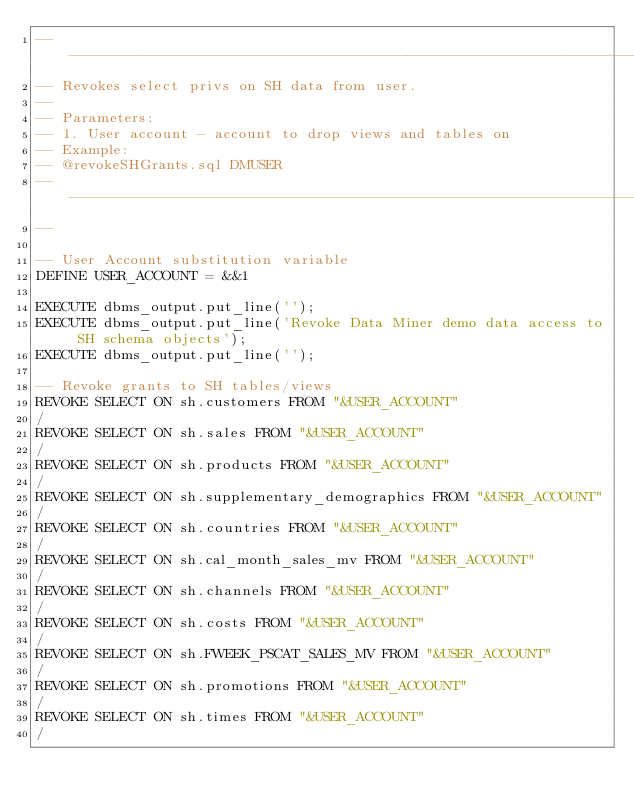Convert code to text. <code><loc_0><loc_0><loc_500><loc_500><_SQL_>--------------------------------------------------------------------------------
-- Revokes select privs on SH data from user.
-- 
-- Parameters:
-- 1. User account - account to drop views and tables on
-- Example:
-- @revokeSHGrants.sql DMUSER
--------------------------------------------------------------------------
--

-- User Account substitution variable
DEFINE USER_ACCOUNT = &&1

EXECUTE dbms_output.put_line('');
EXECUTE dbms_output.put_line('Revoke Data Miner demo data access to SH schema objects');
EXECUTE dbms_output.put_line('');

-- Revoke grants to SH tables/views
REVOKE SELECT ON sh.customers FROM "&USER_ACCOUNT"
/
REVOKE SELECT ON sh.sales FROM "&USER_ACCOUNT"
/
REVOKE SELECT ON sh.products FROM "&USER_ACCOUNT"
/
REVOKE SELECT ON sh.supplementary_demographics FROM "&USER_ACCOUNT"
/
REVOKE SELECT ON sh.countries FROM "&USER_ACCOUNT"
/ 
REVOKE SELECT ON sh.cal_month_sales_mv FROM "&USER_ACCOUNT"
/ 
REVOKE SELECT ON sh.channels FROM "&USER_ACCOUNT"
/ 
REVOKE SELECT ON sh.costs FROM "&USER_ACCOUNT"
/
REVOKE SELECT ON sh.FWEEK_PSCAT_SALES_MV FROM "&USER_ACCOUNT"
/
REVOKE SELECT ON sh.promotions FROM "&USER_ACCOUNT"
/
REVOKE SELECT ON sh.times FROM "&USER_ACCOUNT"
/
</code> 